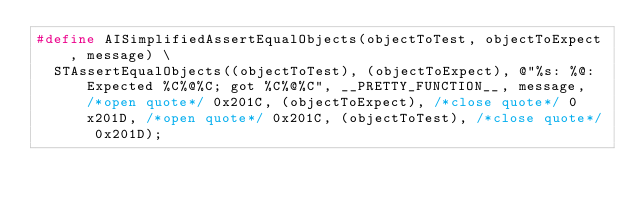Convert code to text. <code><loc_0><loc_0><loc_500><loc_500><_C_>#define AISimplifiedAssertEqualObjects(objectToTest, objectToExpect, message) \
	STAssertEqualObjects((objectToTest), (objectToExpect), @"%s: %@: Expected %C%@%C; got %C%@%C", __PRETTY_FUNCTION__, message, /*open quote*/ 0x201C, (objectToExpect), /*close quote*/ 0x201D, /*open quote*/ 0x201C, (objectToTest), /*close quote*/ 0x201D);
</code> 